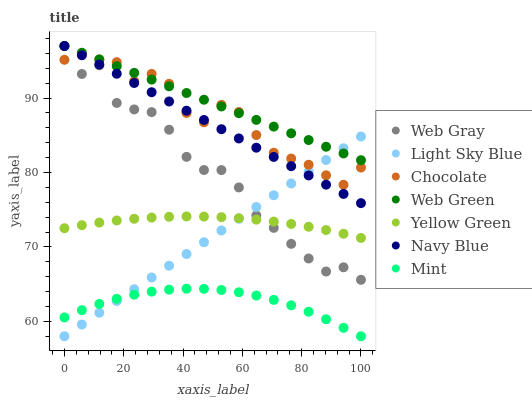Does Mint have the minimum area under the curve?
Answer yes or no. Yes. Does Web Green have the maximum area under the curve?
Answer yes or no. Yes. Does Yellow Green have the minimum area under the curve?
Answer yes or no. No. Does Yellow Green have the maximum area under the curve?
Answer yes or no. No. Is Navy Blue the smoothest?
Answer yes or no. Yes. Is Web Gray the roughest?
Answer yes or no. Yes. Is Yellow Green the smoothest?
Answer yes or no. No. Is Yellow Green the roughest?
Answer yes or no. No. Does Light Sky Blue have the lowest value?
Answer yes or no. Yes. Does Yellow Green have the lowest value?
Answer yes or no. No. Does Web Green have the highest value?
Answer yes or no. Yes. Does Yellow Green have the highest value?
Answer yes or no. No. Is Mint less than Web Gray?
Answer yes or no. Yes. Is Chocolate greater than Yellow Green?
Answer yes or no. Yes. Does Web Gray intersect Navy Blue?
Answer yes or no. Yes. Is Web Gray less than Navy Blue?
Answer yes or no. No. Is Web Gray greater than Navy Blue?
Answer yes or no. No. Does Mint intersect Web Gray?
Answer yes or no. No. 